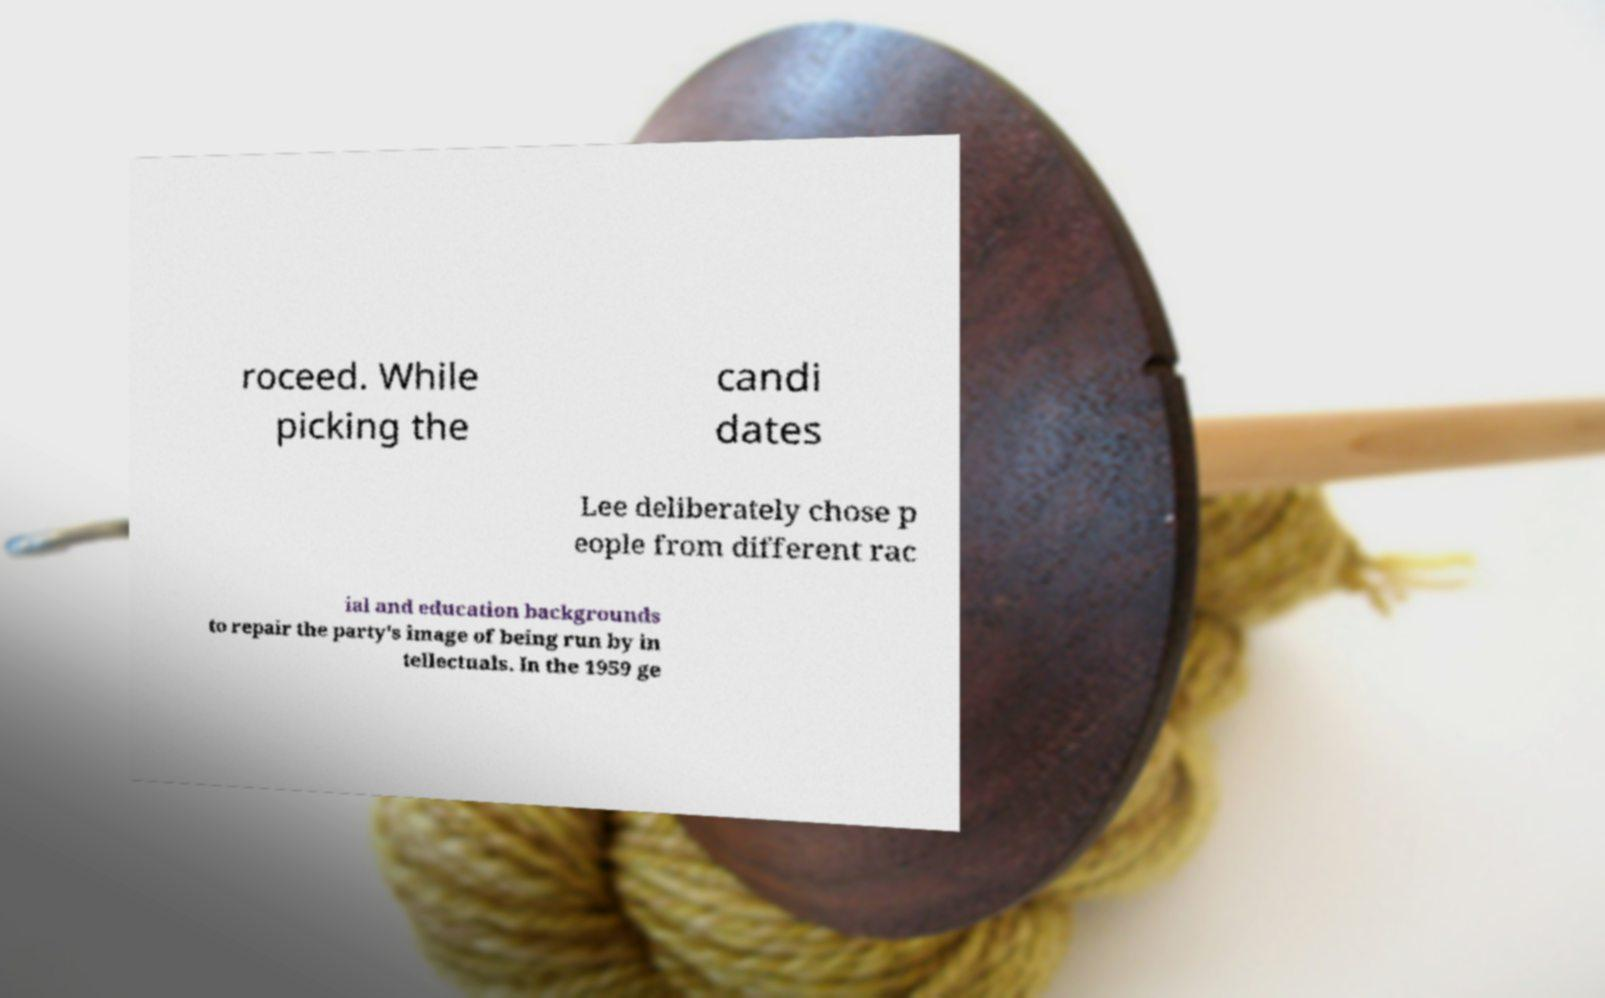What messages or text are displayed in this image? I need them in a readable, typed format. roceed. While picking the candi dates Lee deliberately chose p eople from different rac ial and education backgrounds to repair the party's image of being run by in tellectuals. In the 1959 ge 